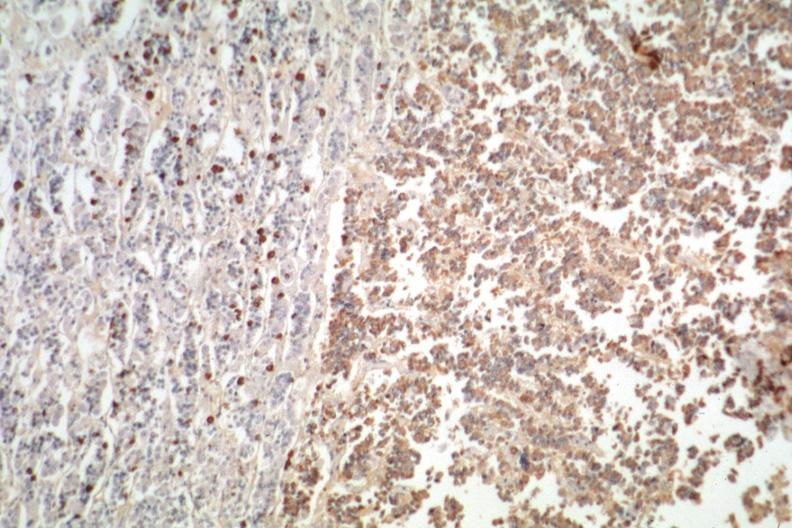what is present?
Answer the question using a single word or phrase. Eosinophilic adenoma 